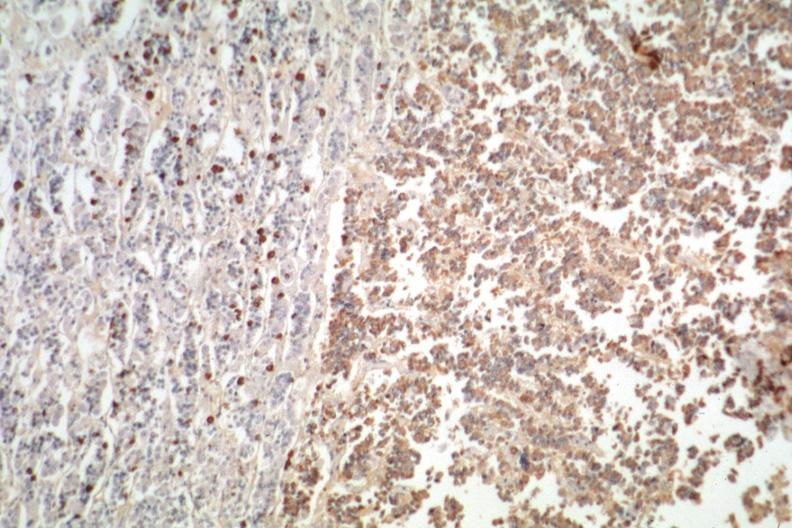what is present?
Answer the question using a single word or phrase. Eosinophilic adenoma 